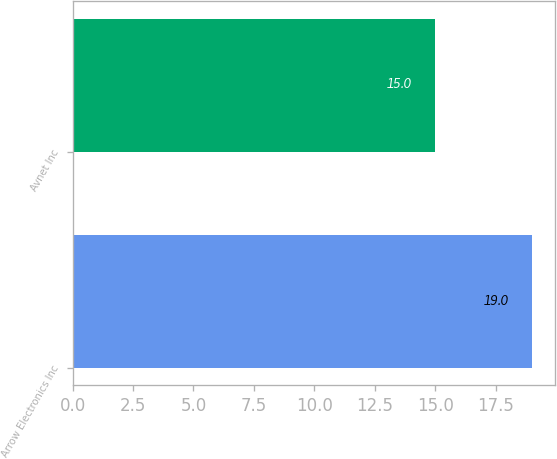<chart> <loc_0><loc_0><loc_500><loc_500><bar_chart><fcel>Arrow Electronics Inc<fcel>Avnet Inc<nl><fcel>19<fcel>15<nl></chart> 